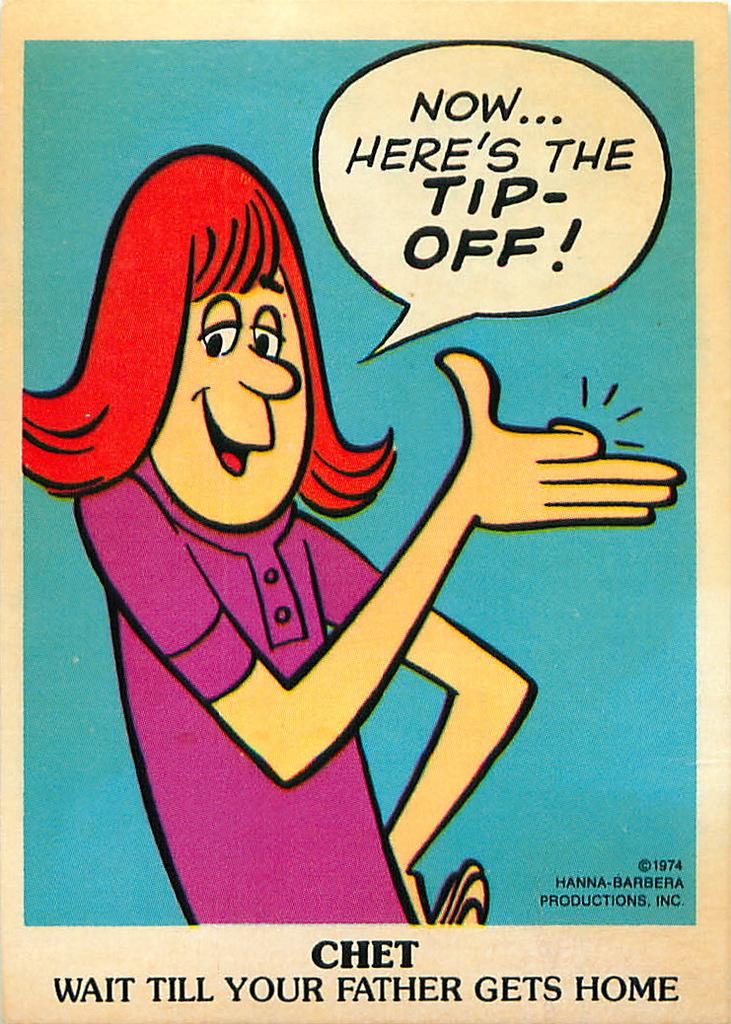<image>
Render a clear and concise summary of the photo. some kind of comic joke about the tip off and waiting for your father to get home 